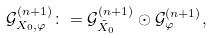Convert formula to latex. <formula><loc_0><loc_0><loc_500><loc_500>\mathcal { G } ^ { ( n + 1 ) } _ { X _ { 0 } , \varphi } \colon = \mathcal { G } ^ { ( n + 1 ) } _ { \tilde { X } _ { 0 } } \odot \mathcal { G } _ { \varphi } ^ { ( n + 1 ) } ,</formula> 